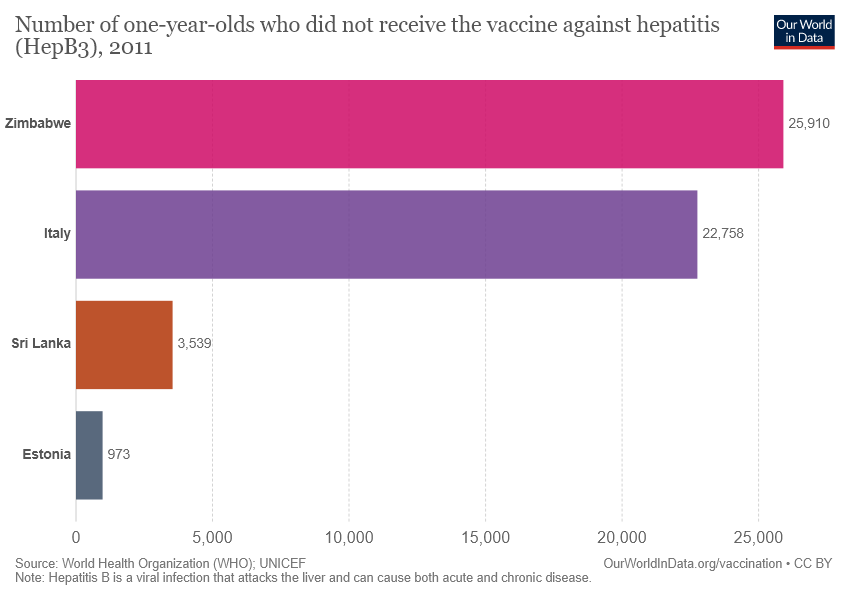List a handful of essential elements in this visual. The value of the smallest bar is 973 and... To make the Estonia value equal to Sri Lanka, 2566 additional value is required. 